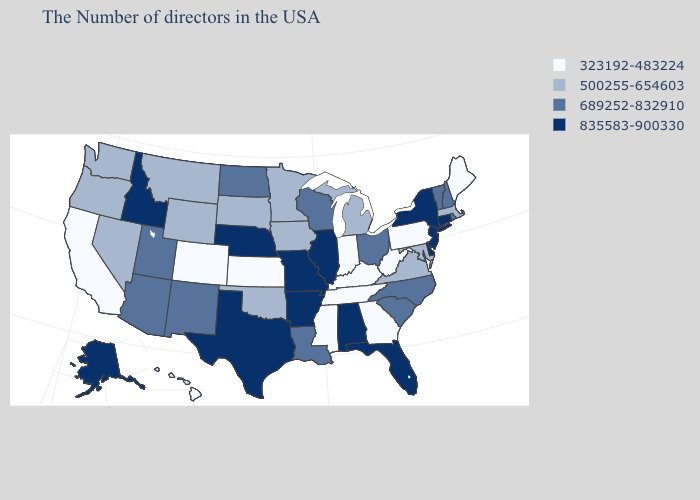Which states hav the highest value in the South?
Give a very brief answer. Delaware, Florida, Alabama, Arkansas, Texas. Name the states that have a value in the range 689252-832910?
Be succinct. Rhode Island, New Hampshire, Vermont, North Carolina, South Carolina, Ohio, Wisconsin, Louisiana, North Dakota, New Mexico, Utah, Arizona. What is the highest value in states that border Vermont?
Give a very brief answer. 835583-900330. What is the value of Massachusetts?
Quick response, please. 500255-654603. What is the value of Idaho?
Keep it brief. 835583-900330. Does Mississippi have the same value as Kansas?
Write a very short answer. Yes. What is the value of Oregon?
Concise answer only. 500255-654603. Which states have the lowest value in the USA?
Quick response, please. Maine, Pennsylvania, West Virginia, Georgia, Kentucky, Indiana, Tennessee, Mississippi, Kansas, Colorado, California, Hawaii. Which states have the highest value in the USA?
Write a very short answer. Connecticut, New York, New Jersey, Delaware, Florida, Alabama, Illinois, Missouri, Arkansas, Nebraska, Texas, Idaho, Alaska. Among the states that border Connecticut , which have the lowest value?
Keep it brief. Massachusetts. Does Florida have the lowest value in the USA?
Short answer required. No. Name the states that have a value in the range 323192-483224?
Quick response, please. Maine, Pennsylvania, West Virginia, Georgia, Kentucky, Indiana, Tennessee, Mississippi, Kansas, Colorado, California, Hawaii. Among the states that border Kentucky , does Tennessee have the lowest value?
Short answer required. Yes. What is the value of Minnesota?
Quick response, please. 500255-654603. Does New Mexico have the same value as Pennsylvania?
Answer briefly. No. 